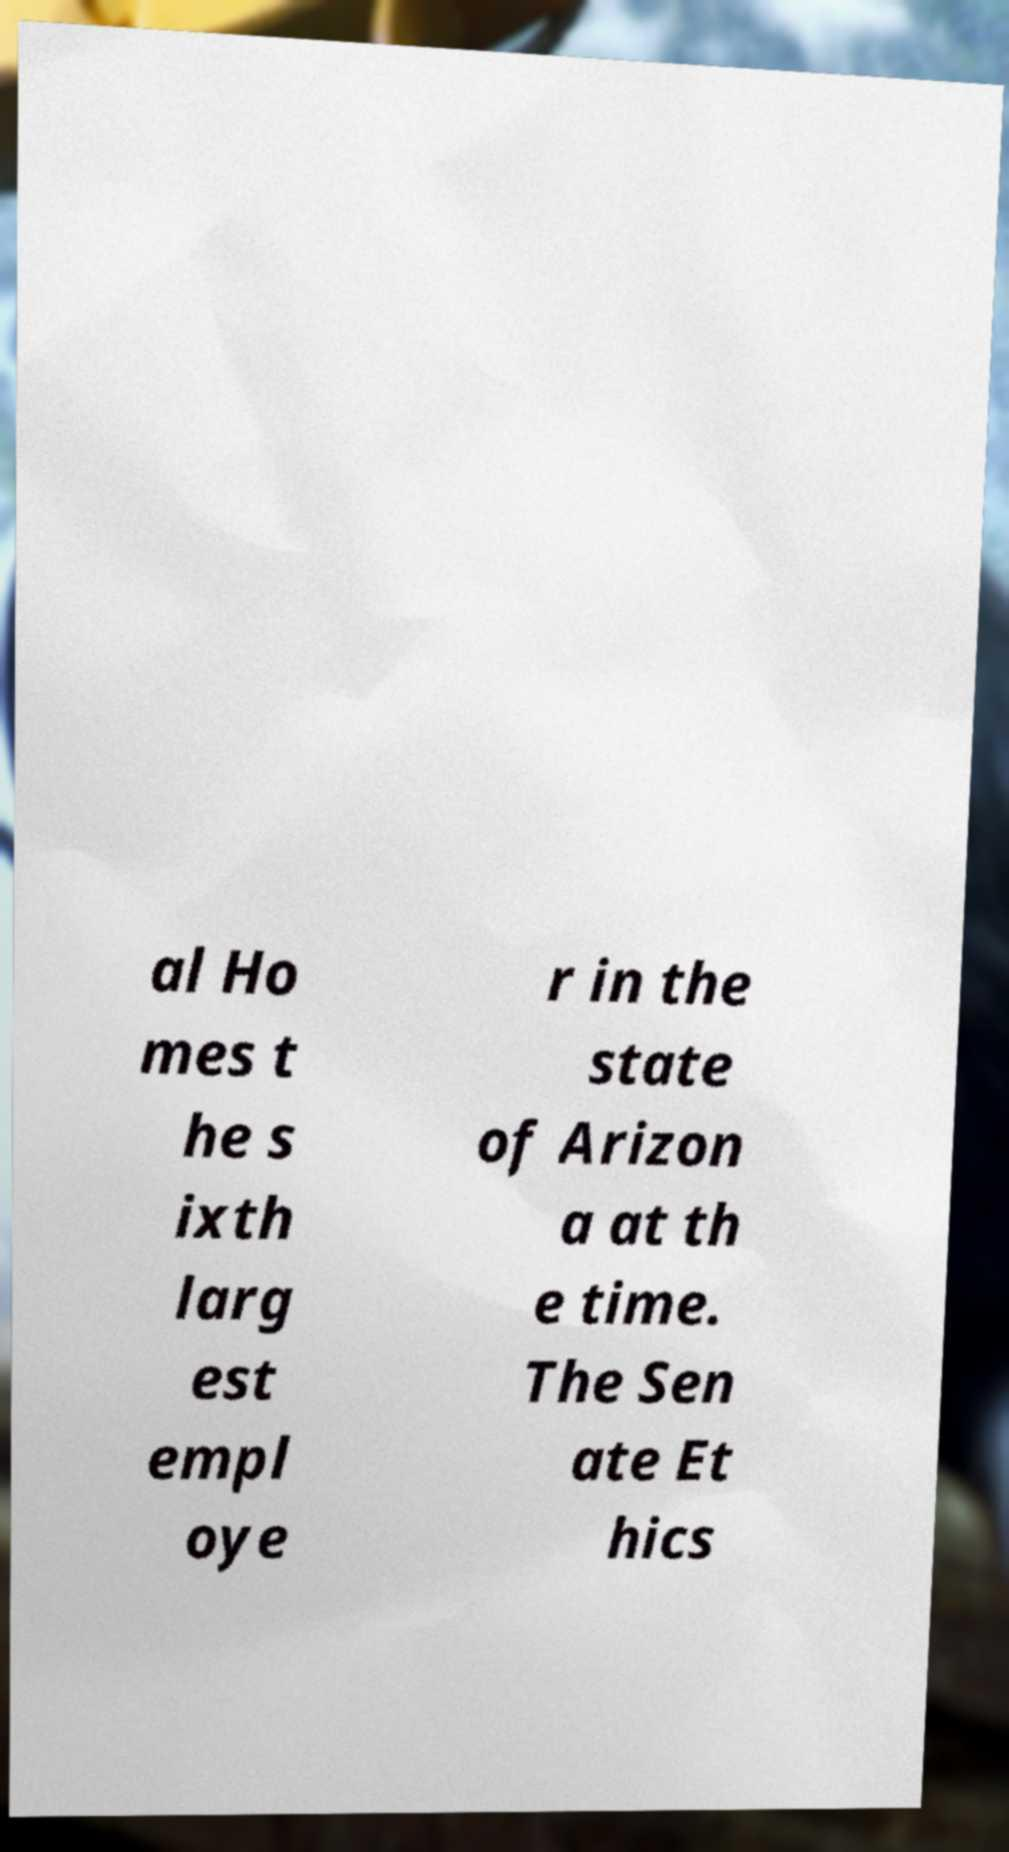Can you accurately transcribe the text from the provided image for me? al Ho mes t he s ixth larg est empl oye r in the state of Arizon a at th e time. The Sen ate Et hics 